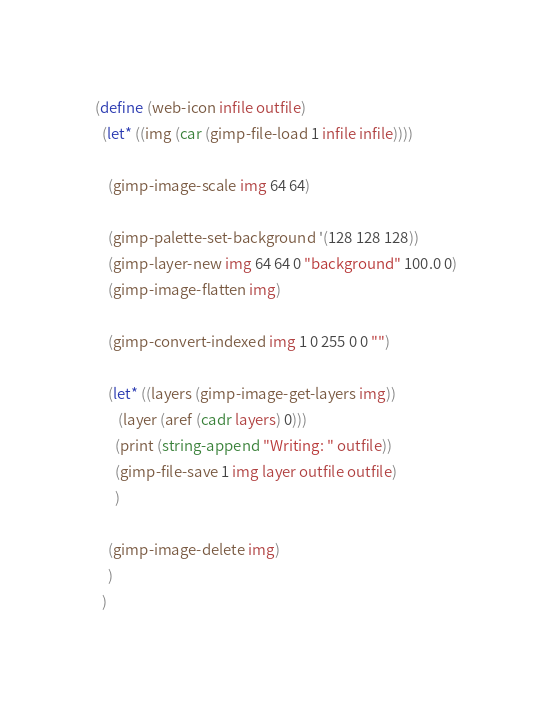Convert code to text. <code><loc_0><loc_0><loc_500><loc_500><_Scheme_>
(define (web-icon infile outfile)
  (let* ((img (car (gimp-file-load 1 infile infile))))

    (gimp-image-scale img 64 64)

    (gimp-palette-set-background '(128 128 128)) 
    (gimp-layer-new img 64 64 0 "background" 100.0 0)
    (gimp-image-flatten img)

    (gimp-convert-indexed img 1 0 255 0 0 "")

    (let* ((layers (gimp-image-get-layers img))
	   (layer (aref (cadr layers) 0)))
      (print (string-append "Writing: " outfile))
      (gimp-file-save 1 img layer outfile outfile)
      )

    (gimp-image-delete img)
    )
  )
</code> 